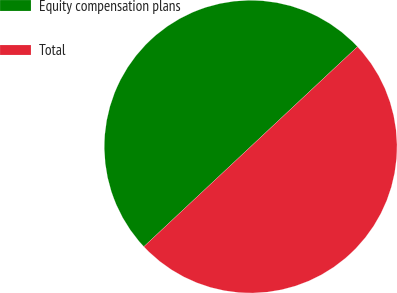Convert chart. <chart><loc_0><loc_0><loc_500><loc_500><pie_chart><fcel>Equity compensation plans<fcel>Total<nl><fcel>50.0%<fcel>50.0%<nl></chart> 